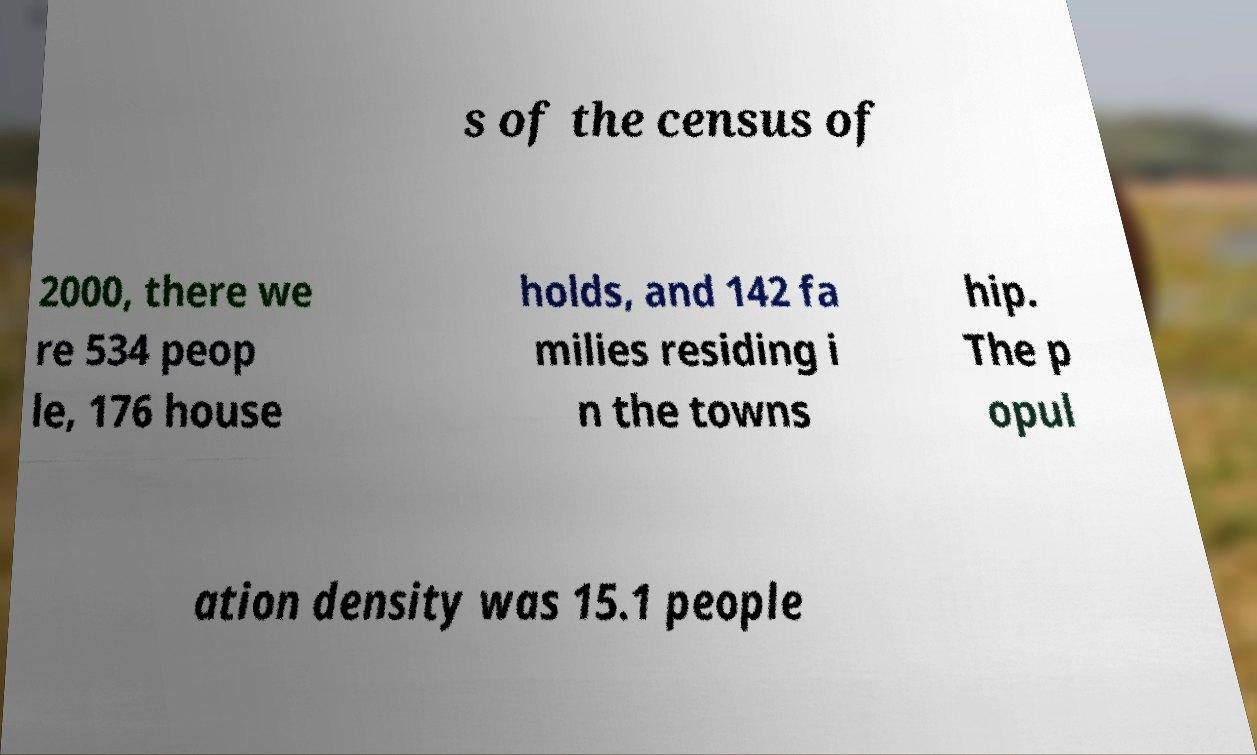For documentation purposes, I need the text within this image transcribed. Could you provide that? s of the census of 2000, there we re 534 peop le, 176 house holds, and 142 fa milies residing i n the towns hip. The p opul ation density was 15.1 people 